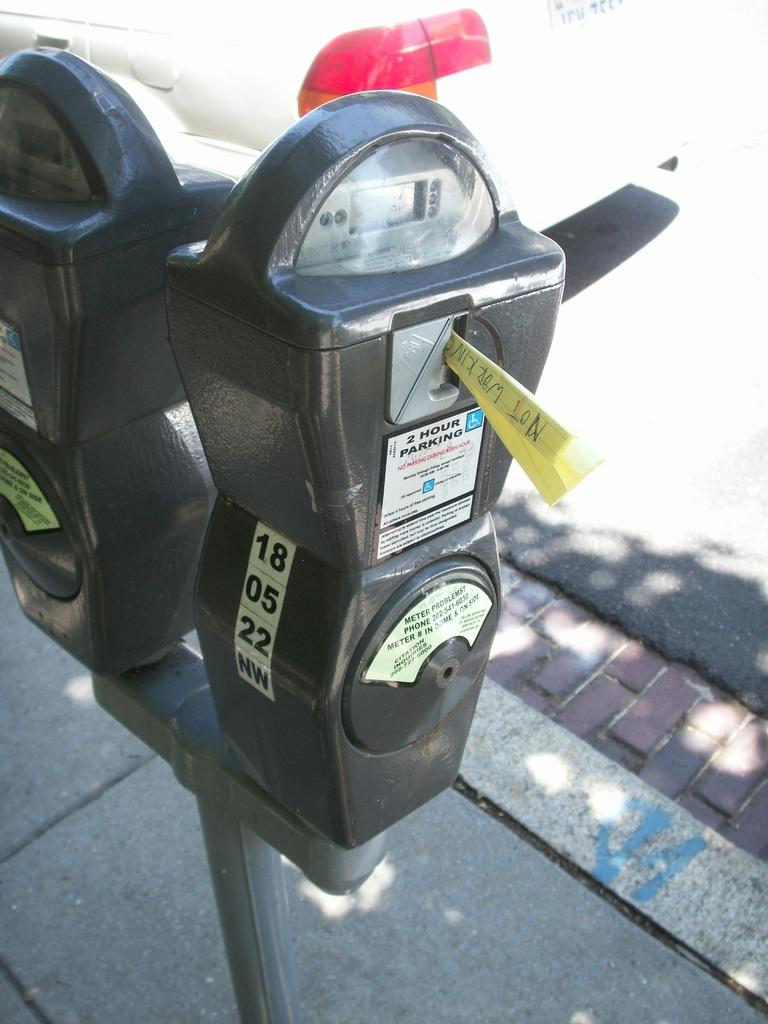<image>
Give a short and clear explanation of the subsequent image. Black parking meter that says 2 Hour parking only. 